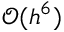<formula> <loc_0><loc_0><loc_500><loc_500>\mathcal { O } ( h ^ { 6 } )</formula> 